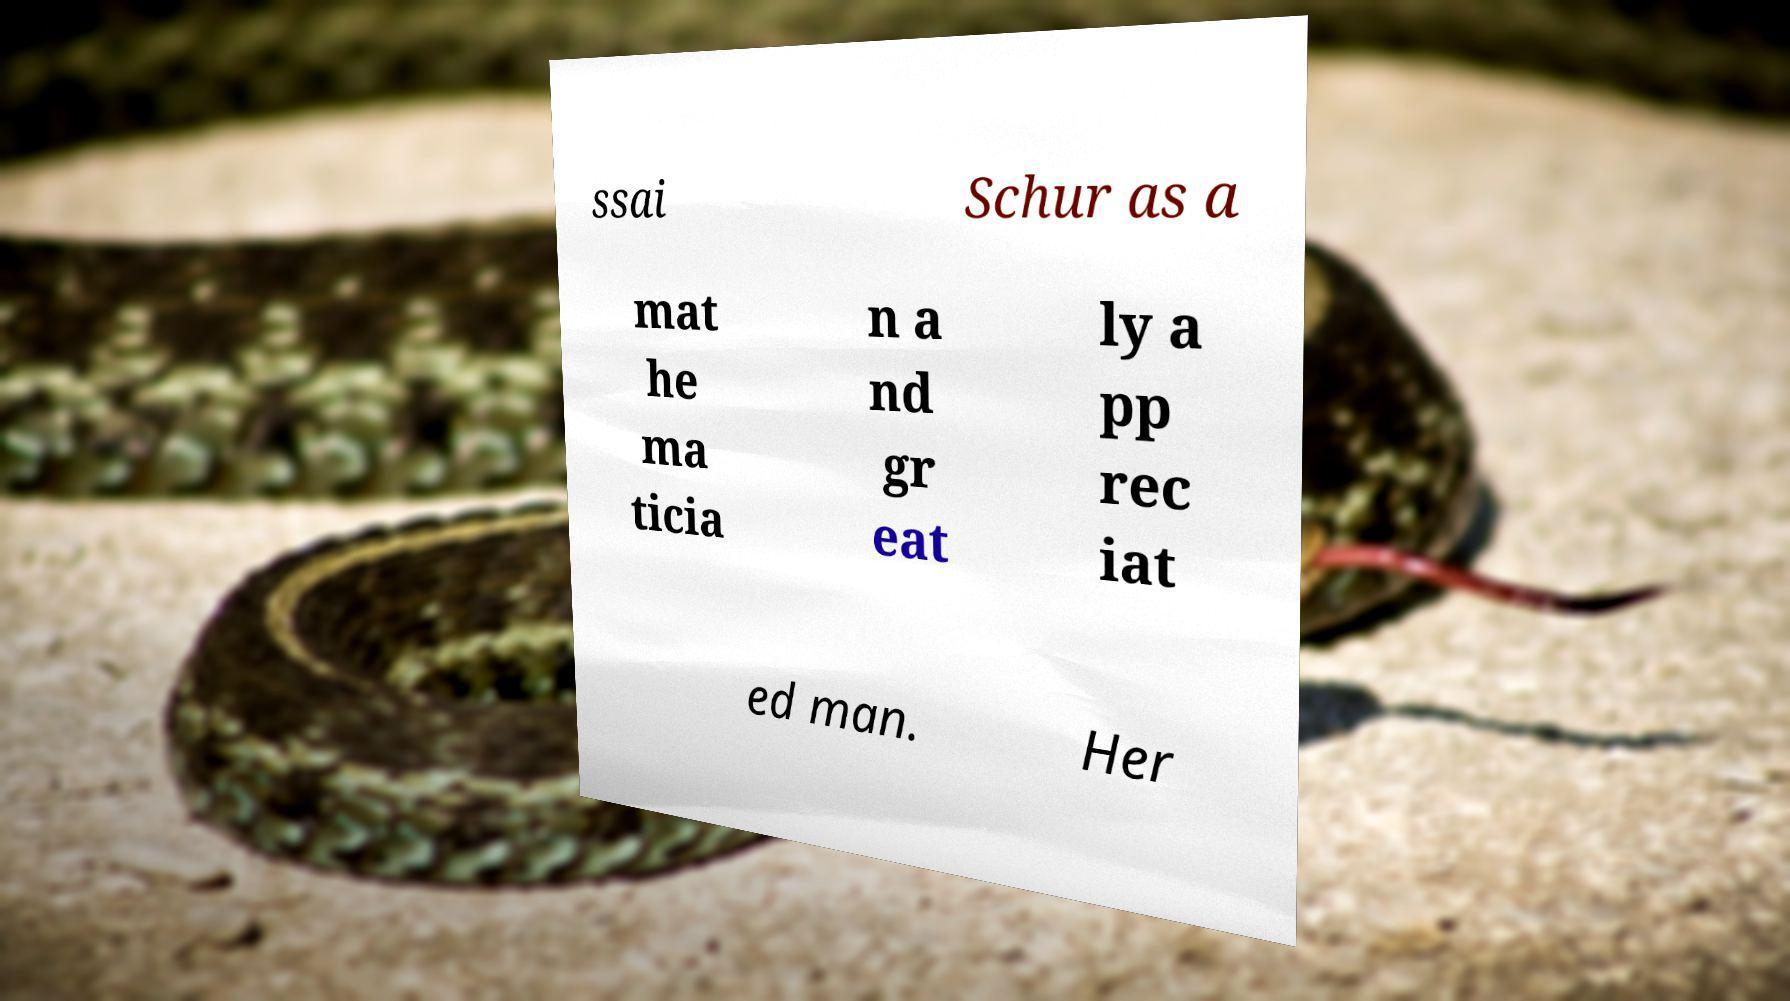Could you extract and type out the text from this image? ssai Schur as a mat he ma ticia n a nd gr eat ly a pp rec iat ed man. Her 